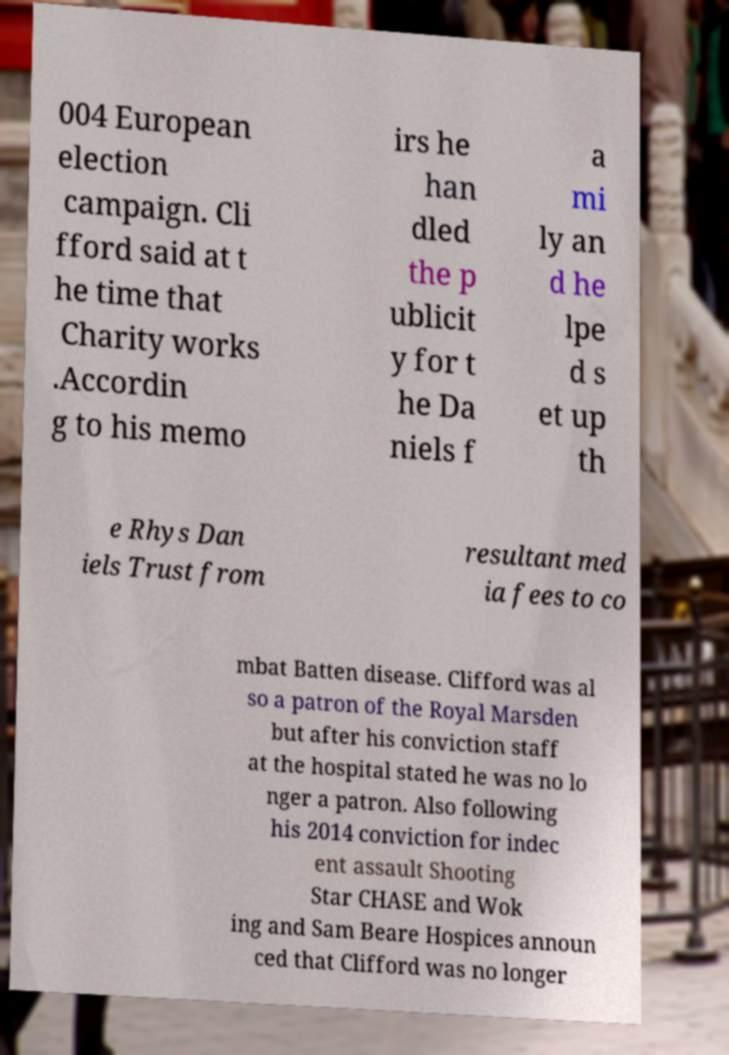There's text embedded in this image that I need extracted. Can you transcribe it verbatim? 004 European election campaign. Cli fford said at t he time that Charity works .Accordin g to his memo irs he han dled the p ublicit y for t he Da niels f a mi ly an d he lpe d s et up th e Rhys Dan iels Trust from resultant med ia fees to co mbat Batten disease. Clifford was al so a patron of the Royal Marsden but after his conviction staff at the hospital stated he was no lo nger a patron. Also following his 2014 conviction for indec ent assault Shooting Star CHASE and Wok ing and Sam Beare Hospices announ ced that Clifford was no longer 